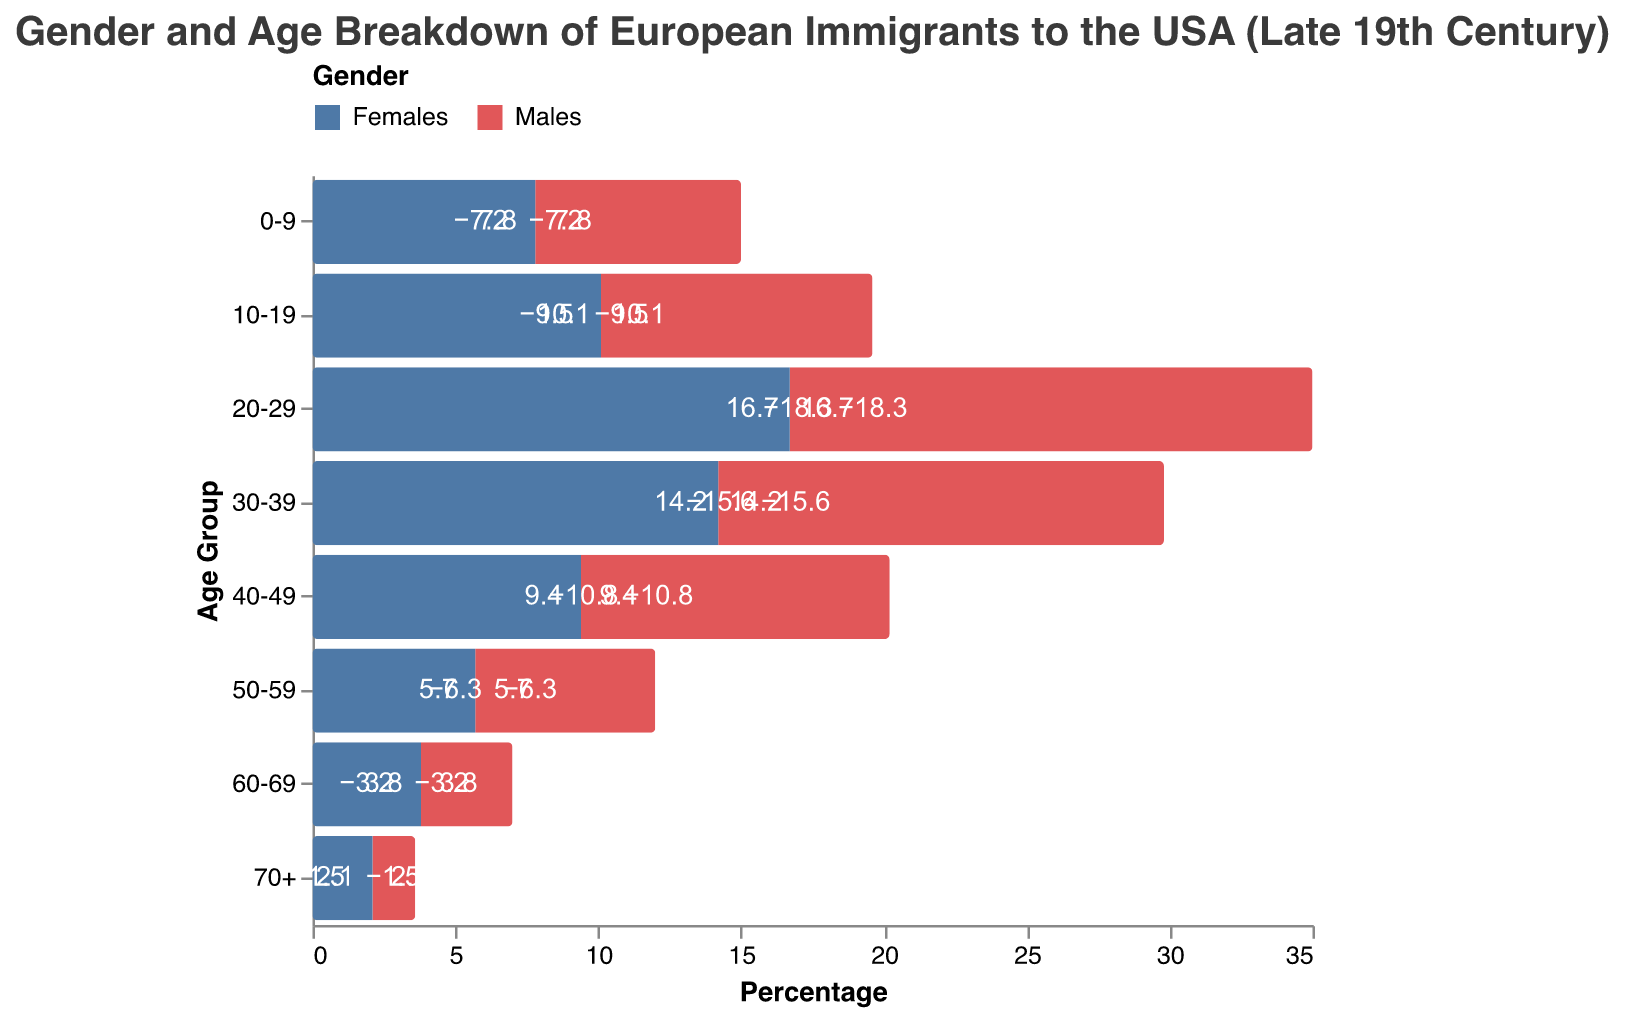what age group has the highest percentage of males? To find the age group with the highest percentage of males, look at the lengths of the bars on the male side (negative values). The longest bar corresponds to the age group 20-29 with -18.3%.
Answer: 20-29 which gender has a higher percentage in the 0-9 age group? Compare the percentages of males and females in the 0-9 age group. Males are 7.2%, and females are 7.8%. Thus, females have a higher percentage.
Answer: Females what is the difference between the percentage of males and females in the 20-29 age group? The percentage of males in the 20-29 age group is 18.3%, and for females, it is 16.7%. The difference is 18.3% - 16.7% = 1.6%.
Answer: 1.6% how many age groups have more males than females? Examine each age group to see if the male percentage is higher than the female percentage. The 20-29, 30-39, and 40-49 age groups have more males than females.
Answer: 3 